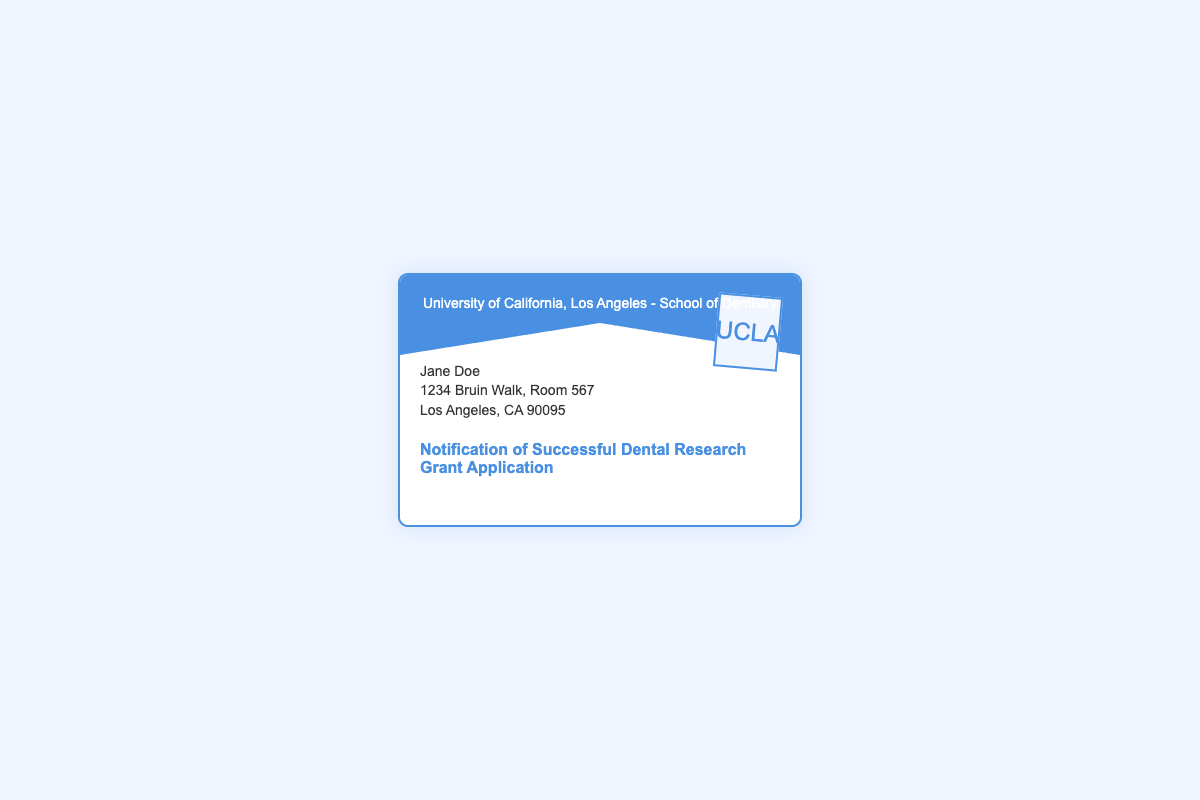What is the name of the institution? The institution is identified in the header of the document as the University of California, Los Angeles - School of Dentistry.
Answer: University of California, Los Angeles - School of Dentistry Who is the recipient of the notification? The recipient's name is mentioned in the document below the header.
Answer: Jane Doe What is the address of the recipient? The address is provided in the recipient section of the document.
Answer: 1234 Bruin Walk, Room 567, Los Angeles, CA 90095 What is the subject of the envelope? The subject line conveys the main purpose of the document, which is stated in bold.
Answer: Notification of Successful Dental Research Grant Application What appears on the stamp? The stamp in the top right corner of the envelope contains the name of the institution.
Answer: UCLA What is the color of the envelope? The envelope is described as having a specific background color and a border color.
Answer: White with a blue border What is the total number of sections in the envelope's content? The content includes various distinct sections categorized by function in the envelope design.
Answer: Three sections What type of notification is this document about? This document specifically relates to a type of application result regarding funding for research.
Answer: Grant Application What is the purpose of the envelope? The envelope serves to inform the recipient about the outcome of their application.
Answer: Notification 